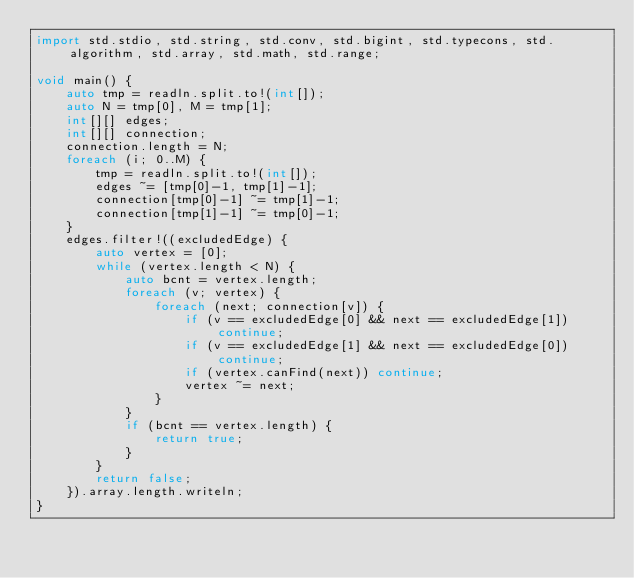<code> <loc_0><loc_0><loc_500><loc_500><_D_>import std.stdio, std.string, std.conv, std.bigint, std.typecons, std.algorithm, std.array, std.math, std.range;
 
void main() {
    auto tmp = readln.split.to!(int[]);
    auto N = tmp[0], M = tmp[1];
    int[][] edges;
    int[][] connection;
    connection.length = N;
    foreach (i; 0..M) {
        tmp = readln.split.to!(int[]);
        edges ~= [tmp[0]-1, tmp[1]-1];
        connection[tmp[0]-1] ~= tmp[1]-1;
        connection[tmp[1]-1] ~= tmp[0]-1;
    }
    edges.filter!((excludedEdge) {
        auto vertex = [0];
        while (vertex.length < N) {
            auto bcnt = vertex.length;
            foreach (v; vertex) {
                foreach (next; connection[v]) {
                    if (v == excludedEdge[0] && next == excludedEdge[1]) continue;
                    if (v == excludedEdge[1] && next == excludedEdge[0]) continue;
                    if (vertex.canFind(next)) continue;
                    vertex ~= next;
                }
            }
            if (bcnt == vertex.length) {
                return true;
            }
        }
        return false;
    }).array.length.writeln;
}</code> 